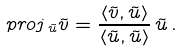<formula> <loc_0><loc_0><loc_500><loc_500>p r o j \, _ { \tilde { u } } { \tilde { v } } = \frac { \left < { \tilde { v } } , { \tilde { u } } \right > } { \left < { \tilde { u } } , { \tilde { u } } \right > } \, { \tilde { u } } \, .</formula> 